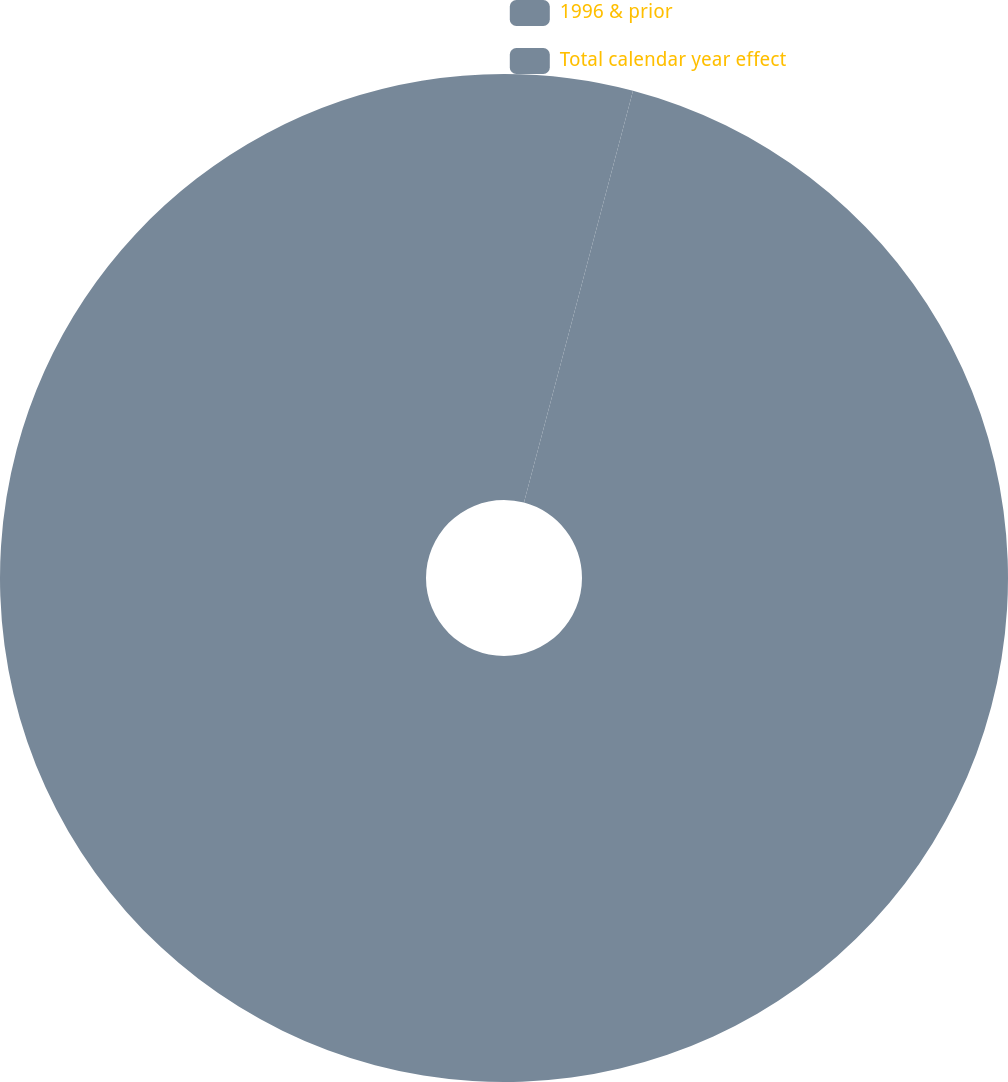Convert chart. <chart><loc_0><loc_0><loc_500><loc_500><pie_chart><fcel>1996 & prior<fcel>Total calendar year effect<nl><fcel>4.12%<fcel>95.88%<nl></chart> 